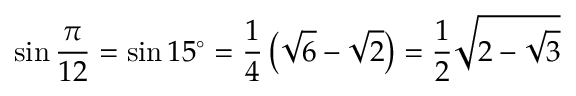<formula> <loc_0><loc_0><loc_500><loc_500>\sin { \frac { \pi } { 1 2 } } = \sin 1 5 ^ { \circ } = { \frac { 1 } { 4 } } \left ( { \sqrt { 6 } } - { \sqrt { 2 } } \right ) = { \frac { 1 } { 2 } } { \sqrt { 2 - { \sqrt { 3 } } } }</formula> 